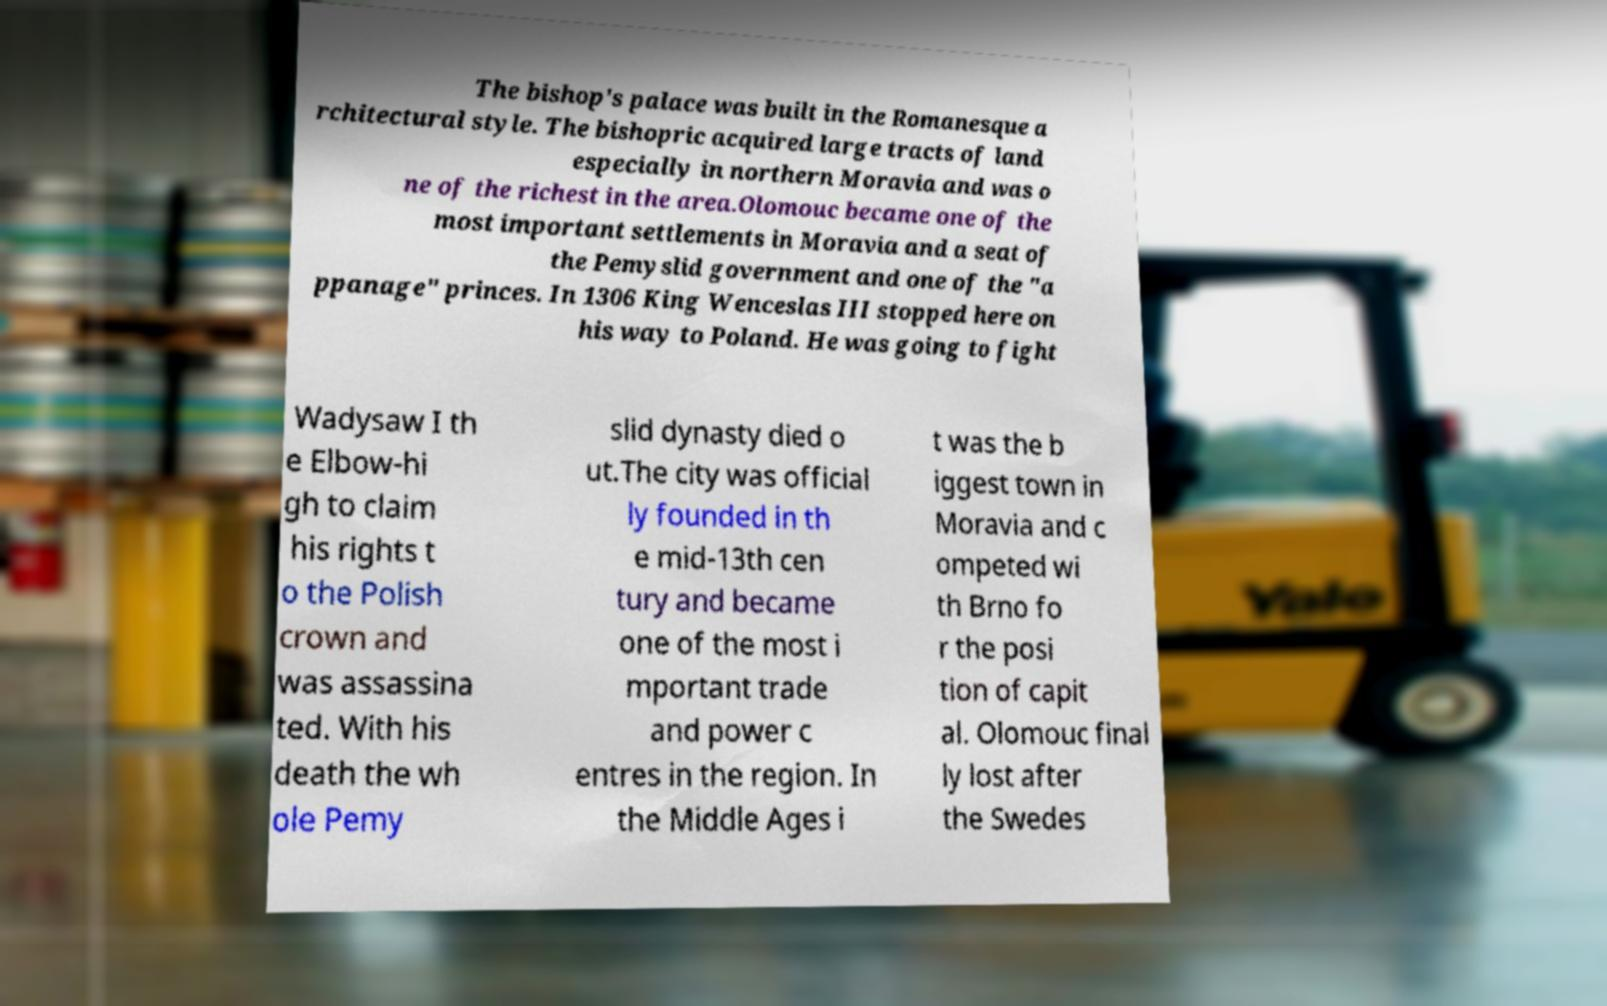Please identify and transcribe the text found in this image. The bishop's palace was built in the Romanesque a rchitectural style. The bishopric acquired large tracts of land especially in northern Moravia and was o ne of the richest in the area.Olomouc became one of the most important settlements in Moravia and a seat of the Pemyslid government and one of the "a ppanage" princes. In 1306 King Wenceslas III stopped here on his way to Poland. He was going to fight Wadysaw I th e Elbow-hi gh to claim his rights t o the Polish crown and was assassina ted. With his death the wh ole Pemy slid dynasty died o ut.The city was official ly founded in th e mid-13th cen tury and became one of the most i mportant trade and power c entres in the region. In the Middle Ages i t was the b iggest town in Moravia and c ompeted wi th Brno fo r the posi tion of capit al. Olomouc final ly lost after the Swedes 